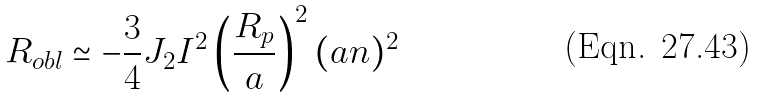Convert formula to latex. <formula><loc_0><loc_0><loc_500><loc_500>R _ { o b l } \simeq - \frac { 3 } { 4 } J _ { 2 } I ^ { 2 } \left ( \frac { R _ { p } } { a } \right ) ^ { 2 } ( a n ) ^ { 2 }</formula> 